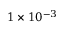Convert formula to latex. <formula><loc_0><loc_0><loc_500><loc_500>1 \times 1 0 ^ { - 3 }</formula> 